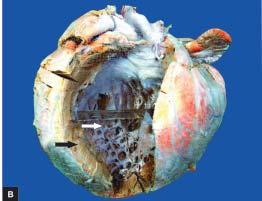s the heart heavier?
Answer the question using a single word or phrase. Yes 